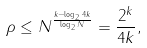<formula> <loc_0><loc_0><loc_500><loc_500>\rho & \leq N ^ { \frac { k - \log _ { 2 } 4 k } { \log _ { 2 } N } } = \frac { 2 ^ { k } } { 4 k } ,</formula> 